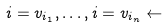<formula> <loc_0><loc_0><loc_500><loc_500>i = v _ { i _ { 1 } } , \dots , i = v _ { i _ { n } } \leftarrow</formula> 